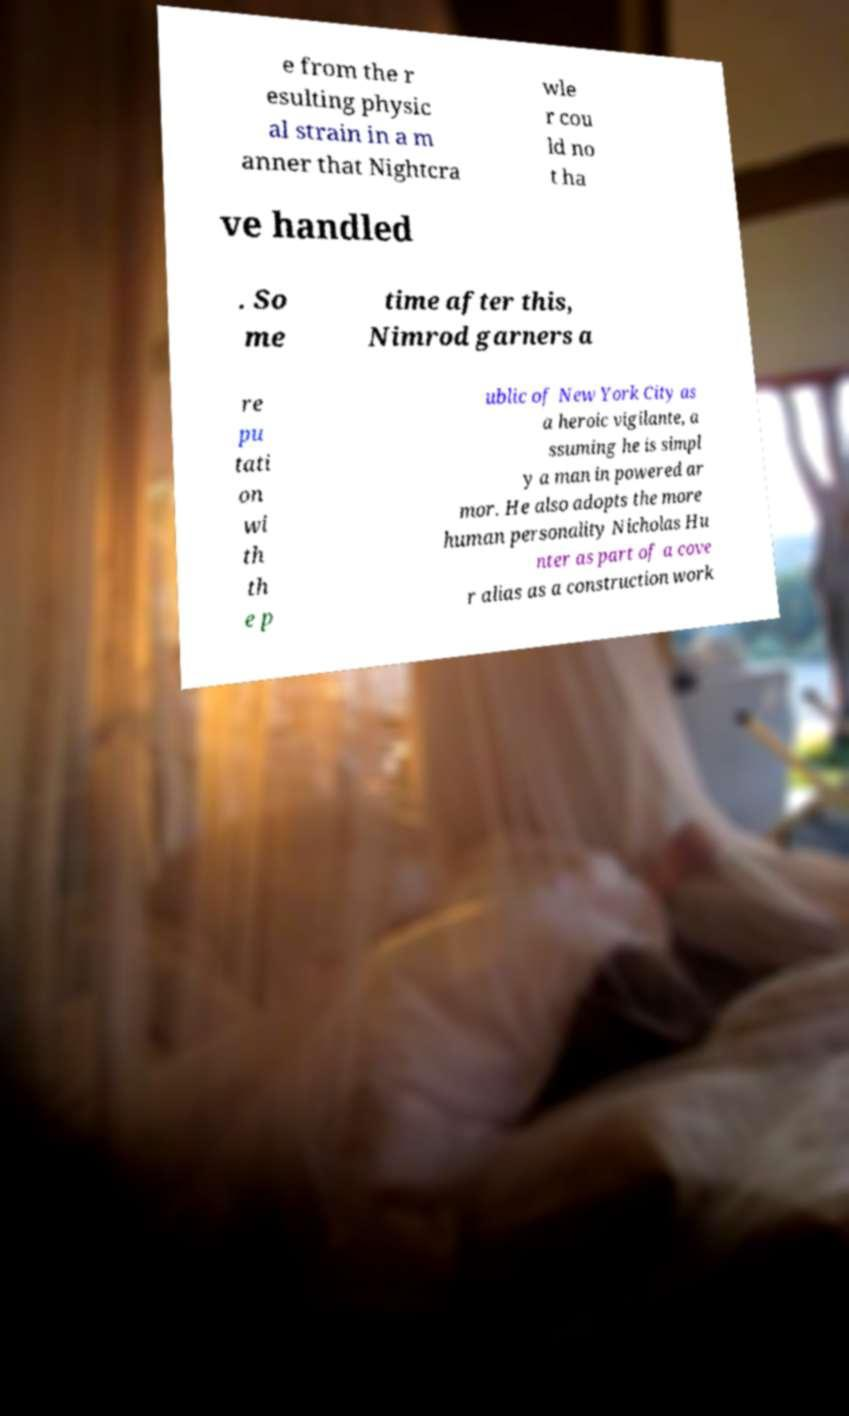Please identify and transcribe the text found in this image. e from the r esulting physic al strain in a m anner that Nightcra wle r cou ld no t ha ve handled . So me time after this, Nimrod garners a re pu tati on wi th th e p ublic of New York City as a heroic vigilante, a ssuming he is simpl y a man in powered ar mor. He also adopts the more human personality Nicholas Hu nter as part of a cove r alias as a construction work 